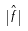Convert formula to latex. <formula><loc_0><loc_0><loc_500><loc_500>| \hat { f } |</formula> 